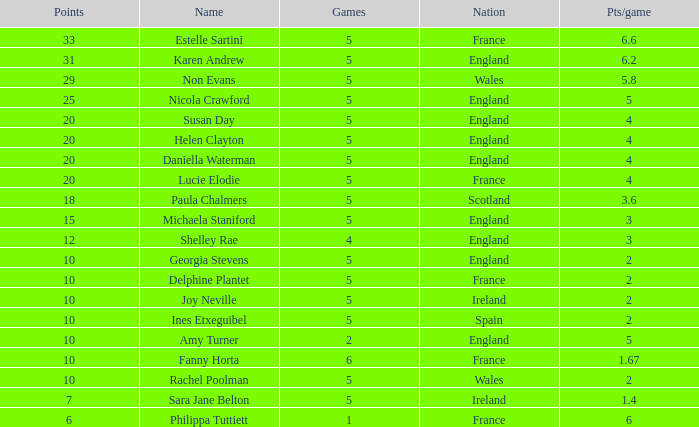Can you tell me the lowest Pts/game that has the Name of philippa tuttiett, and the Points larger then 6? None. 